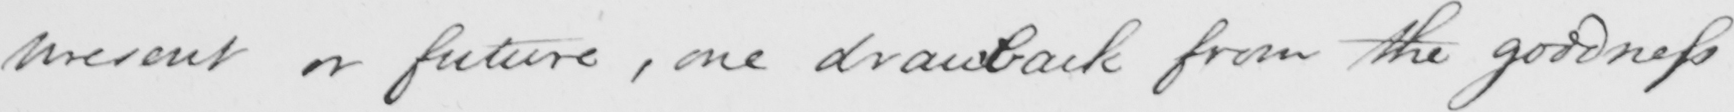Please transcribe the handwritten text in this image. present or future , one drawback from the goodness 